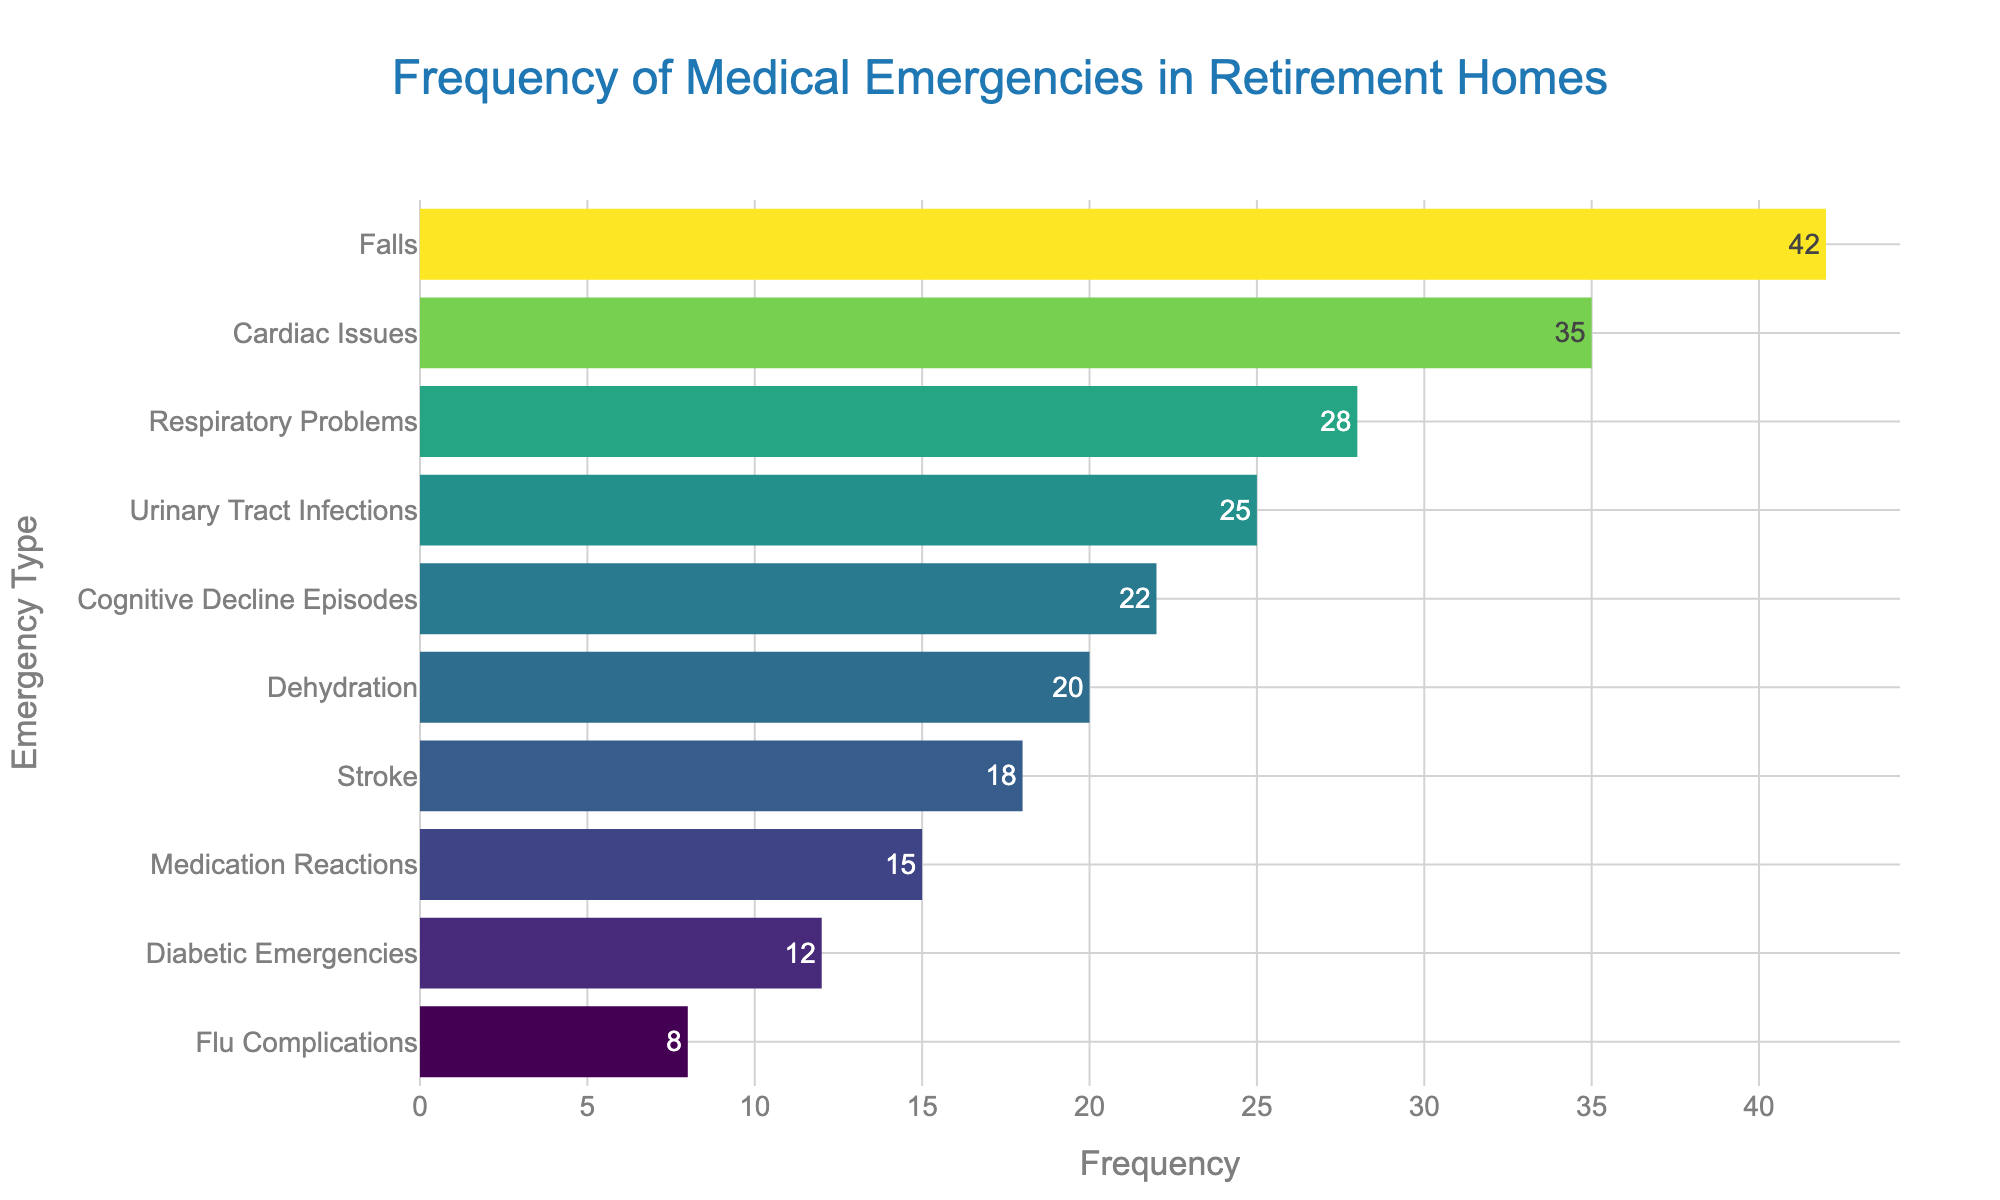What's the title of the plot? The title is usually placed at the top center of the plot, displaying the main subject. Here, the title is "Frequency of Medical Emergencies in Retirement Homes."
Answer: Frequency of Medical Emergencies in Retirement Homes What does the x-axis represent? The x-axis typically represents the numerical values in horizontal bar plots. In this plot, the x-axis represents the frequency of each type of medical emergency.
Answer: Frequency What are the highest and lowest frequency values displayed? By examining the farthest right and left positions along the x-axis, the highest frequency is 42 (Falls), and the lowest is 8 (Flu Complications).
Answer: Highest: 42 (Falls), Lowest: 8 (Flu Complications) How many types of medical emergencies are plotted? Count the distinct horizontal bars representing different medical emergencies. There are 10 types of emergencies plotted.
Answer: 10 Which medical emergency is the most frequent? Identify the bar that extends furthest to the right. The most frequent medical emergency is Falls with a frequency of 42.
Answer: Falls What is the total frequency of all medical emergencies combined? Sum the frequency values of all the bars: 42 + 35 + 28 + 18 + 25 + 20 + 15 + 22 + 12 + 8 = 225.
Answer: 225 How does the frequency of Cardiac Issues compare to Respiratory Problems? Locate and compare the lengths of the bars for Cardiac Issues (35) and Respiratory Problems (28). Cardiac Issues are more frequent.
Answer: Cardiac Issues are more frequent What is the median frequency value of the emergencies? List the frequencies in ascending order: 8, 12, 15, 18, 20, 22, 25, 28, 35, 42. The median is the middle value in this ordered list, which is the average of the 5th and 6th values: (20 + 22)/2 = 21.
Answer: 21 Which emergencies have a frequency higher than 20? Identify bars that extend beyond the 20 mark on the x-axis. These are: Falls (42), Cardiac Issues (35), Respiratory Problems (28), Urinary Tract Infections (25), Dehydration (20), and Cognitive Decline Episodes (22).
Answer: Falls, Cardiac Issues, Respiratory Problems, Urinary Tract Infections, Cognitive Decline Episodes How do the frequencies of Cognitive Decline Episodes and Diabetic Emergencies differ? Compare the bar lengths for Cognitive Decline Episodes (22) and Diabetic Emergencies (12). The difference is 22 - 12 = 10.
Answer: 10 